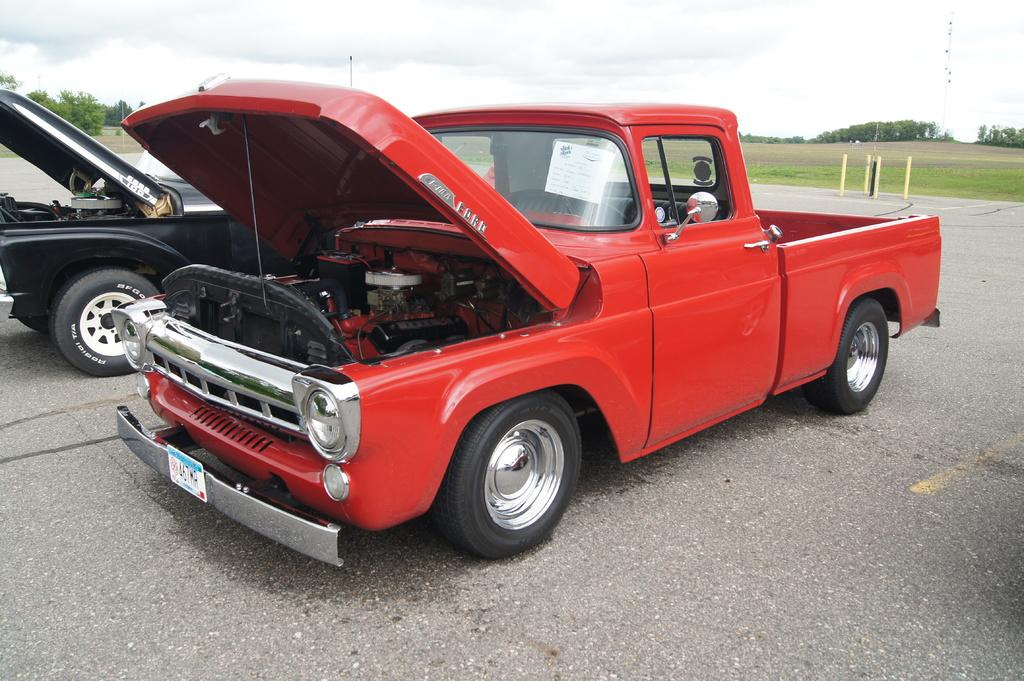How many vehicles can be seen parked on the road in the image? There are two vehicles parked on the road in the image. What is located behind the vehicles? There are poles and trees behind the vehicles. What is the condition of the sky in the image? The sky is cloudy in the image. Can you see any pickles growing on the trees in the image? There are no pickles present in the image; the trees are not shown to have any fruits or vegetables growing on them. What type of liquid is being poured from the wing of the vehicle in the image? There are no vehicles with wings in the image, and therefore no liquid can be seen being poured from a wing. 